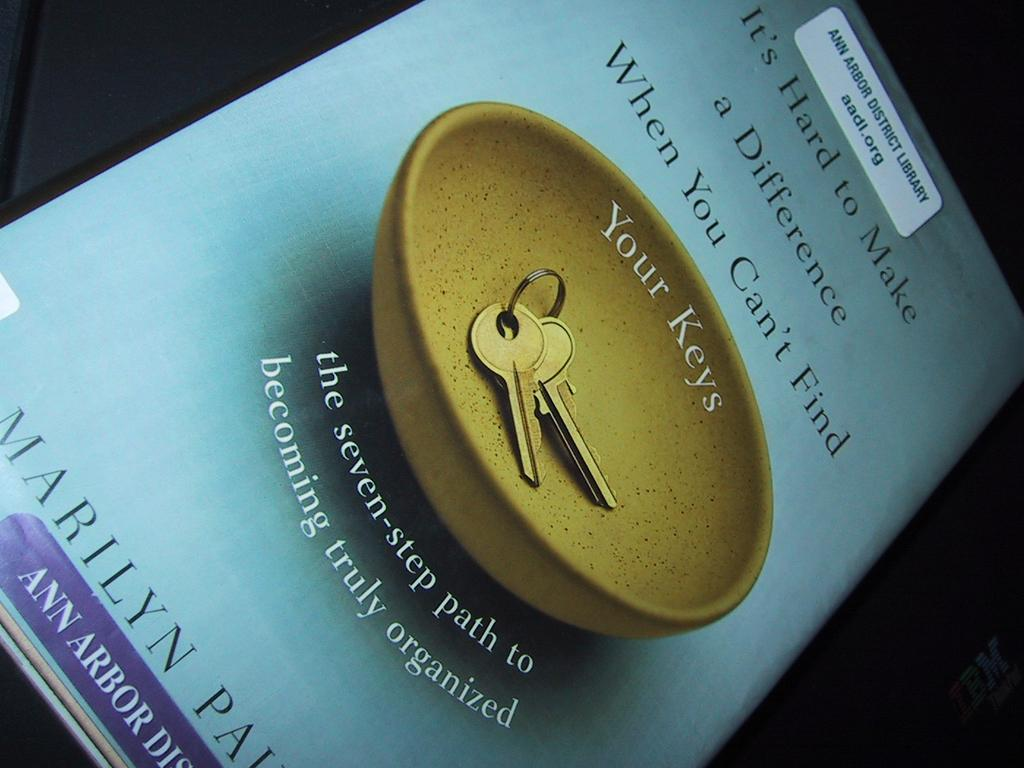<image>
Describe the image concisely. Book with a bowl and keys on the cover and the text "Your Keys". 